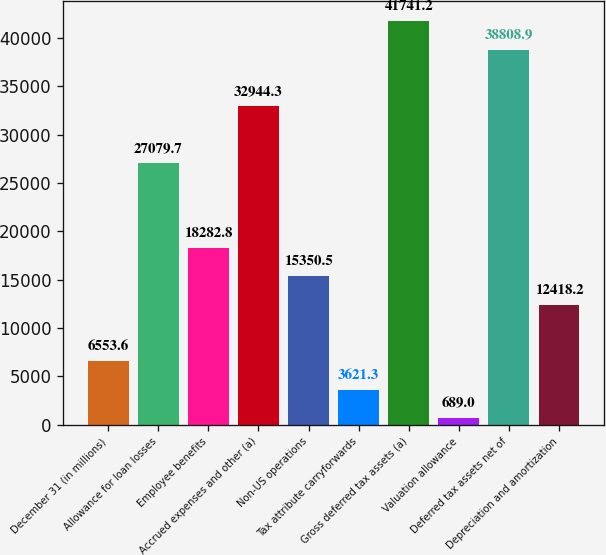Convert chart to OTSL. <chart><loc_0><loc_0><loc_500><loc_500><bar_chart><fcel>December 31 (in millions)<fcel>Allowance for loan losses<fcel>Employee benefits<fcel>Accrued expenses and other (a)<fcel>Non-US operations<fcel>Tax attribute carryforwards<fcel>Gross deferred tax assets (a)<fcel>Valuation allowance<fcel>Deferred tax assets net of<fcel>Depreciation and amortization<nl><fcel>6553.6<fcel>27079.7<fcel>18282.8<fcel>32944.3<fcel>15350.5<fcel>3621.3<fcel>41741.2<fcel>689<fcel>38808.9<fcel>12418.2<nl></chart> 